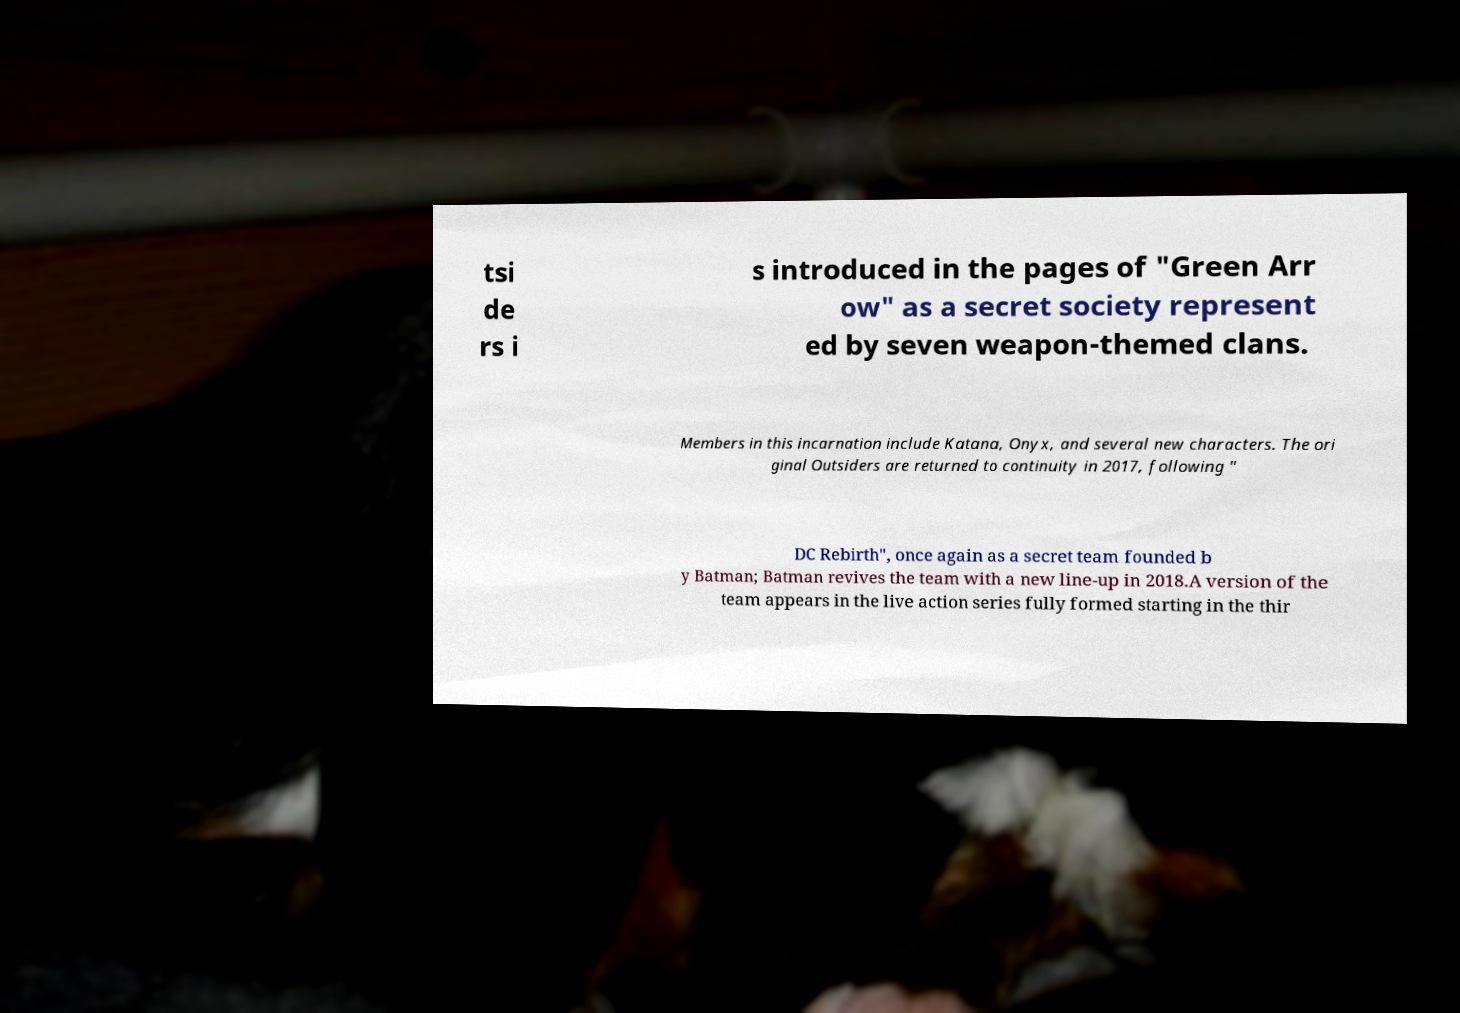Can you read and provide the text displayed in the image?This photo seems to have some interesting text. Can you extract and type it out for me? tsi de rs i s introduced in the pages of "Green Arr ow" as a secret society represent ed by seven weapon-themed clans. Members in this incarnation include Katana, Onyx, and several new characters. The ori ginal Outsiders are returned to continuity in 2017, following " DC Rebirth", once again as a secret team founded b y Batman; Batman revives the team with a new line-up in 2018.A version of the team appears in the live action series fully formed starting in the thir 